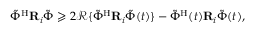Convert formula to latex. <formula><loc_0><loc_0><loc_500><loc_500>\begin{array} { r } { { { \tilde { \Phi } } } ^ { \mathrm H } { R } _ { i } { { \tilde { \Phi } } } \geqslant 2 { \mathcal { R } } \{ { { \tilde { \Phi } } } ^ { \mathrm H } { R } _ { i } { { \tilde { \Phi } } } ( t ) \} - { { \tilde { \Phi } } } ^ { \mathrm H } ( t ) { R } _ { i } { { \tilde { \Phi } } } ( t ) , } \end{array}</formula> 